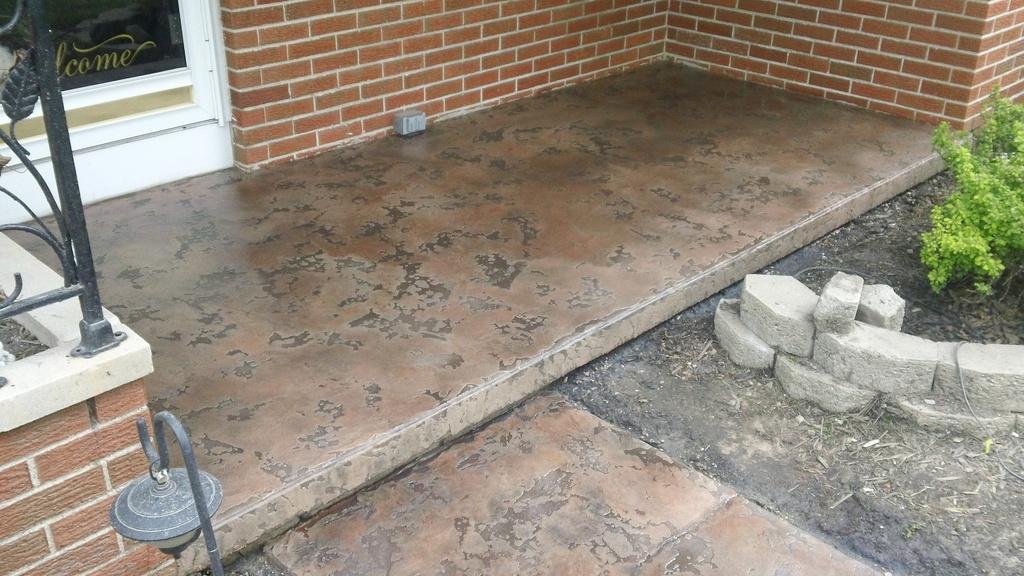In one or two sentences, can you explain what this image depicts? In this picture we can see few metal rods and some text on the glass, on the right side of the image we can see bricks and a plant. 